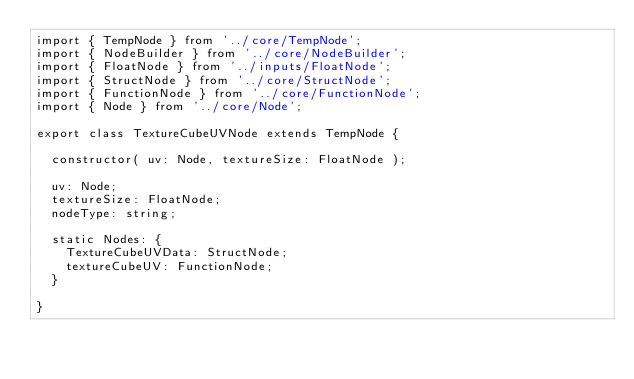Convert code to text. <code><loc_0><loc_0><loc_500><loc_500><_TypeScript_>import { TempNode } from '../core/TempNode';
import { NodeBuilder } from '../core/NodeBuilder';
import { FloatNode } from '../inputs/FloatNode';
import { StructNode } from '../core/StructNode';
import { FunctionNode } from '../core/FunctionNode';
import { Node } from '../core/Node';

export class TextureCubeUVNode extends TempNode {

	constructor( uv: Node, textureSize: FloatNode );

	uv: Node;
	textureSize: FloatNode;
	nodeType: string;

	static Nodes: {
		TextureCubeUVData: StructNode;
		textureCubeUV: FunctionNode;
	}

}
</code> 